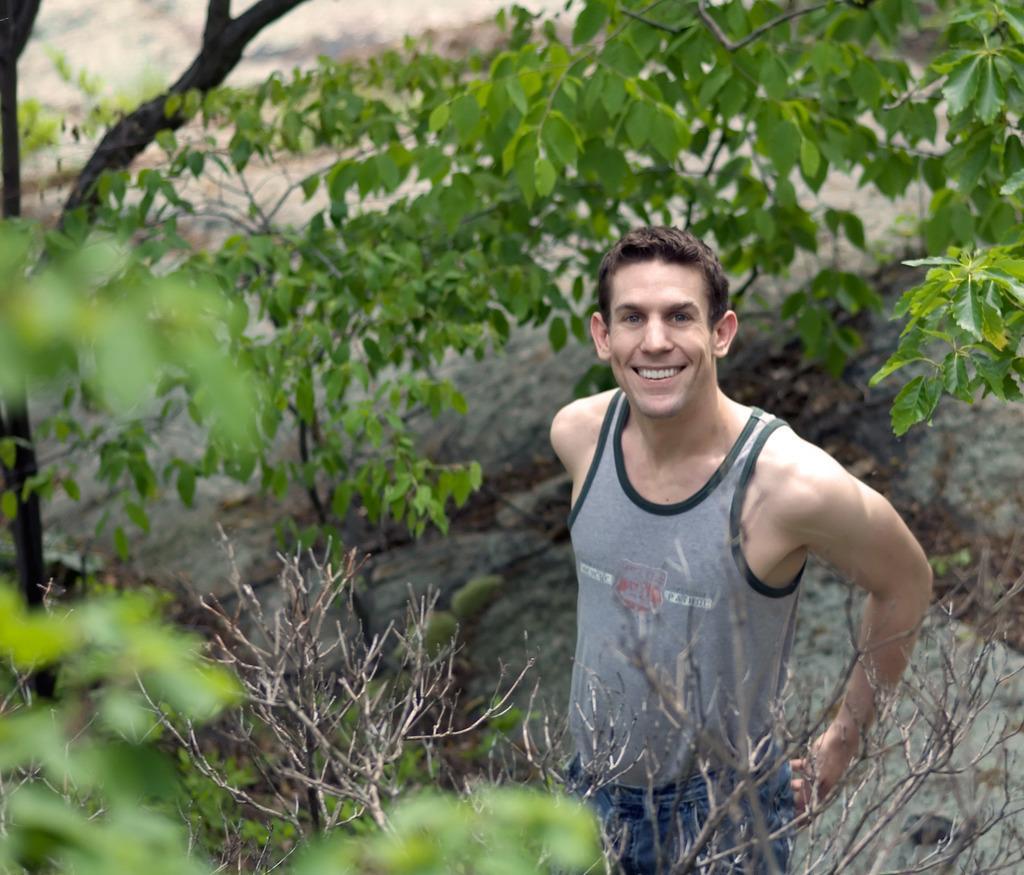Describe this image in one or two sentences. In this image we can see a person standing and smiling and there are some trees around him. 